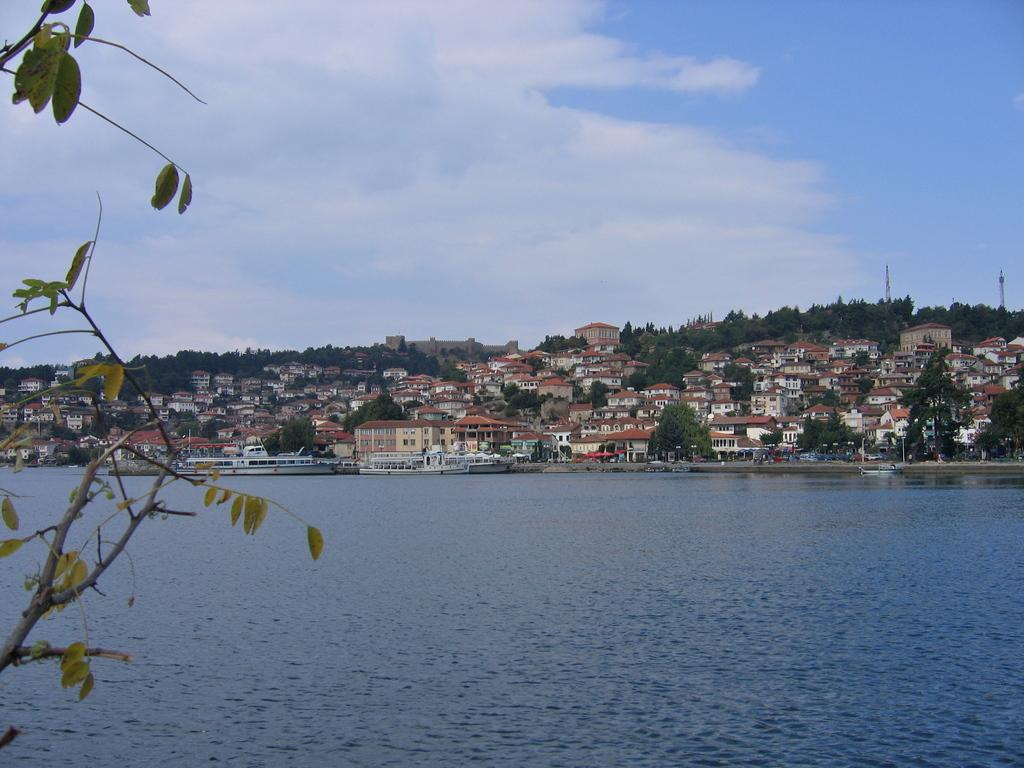What is the primary element in the image? There is water in the image. What structures can be seen near the water? There are houses in the image. What type of vegetation is present in the image? Trees are present in the image. What is visible in the background of the image? The sky is visible in the image. What can be observed in the sky? Clouds are visible in the sky. How many screws can be seen holding the man's place in the image? There is no man or screws present in the image. 